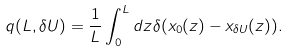<formula> <loc_0><loc_0><loc_500><loc_500>q ( L , \delta U ) = \frac { 1 } { L } \int _ { 0 } ^ { L } d z \delta ( x _ { 0 } ( z ) - x _ { \delta U } ( z ) ) .</formula> 